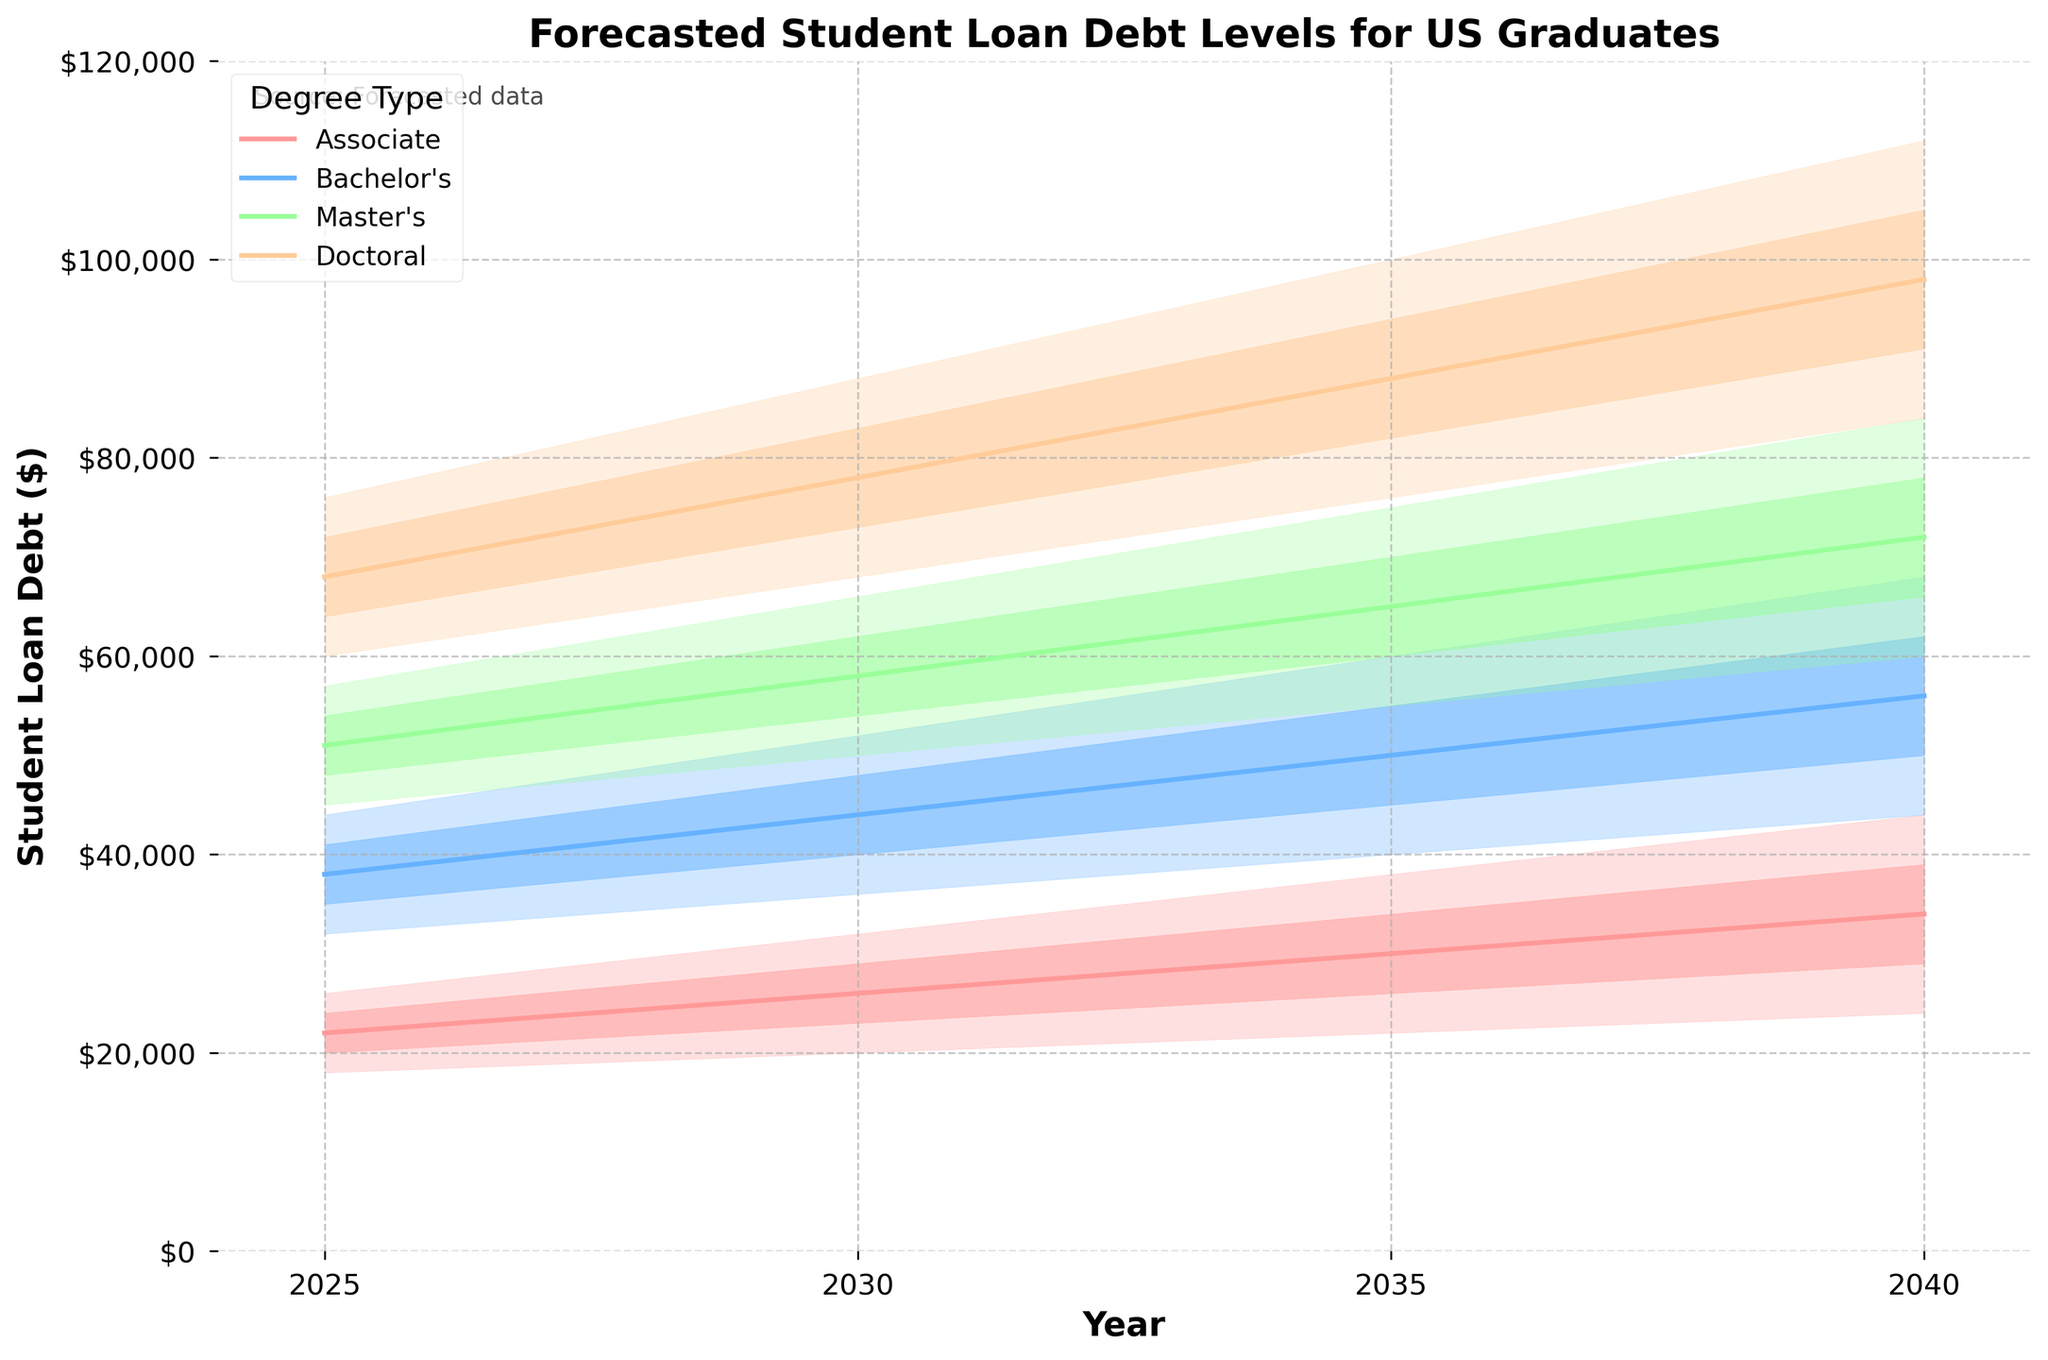What is the title of the figure? The title is usually the text at the top of the chart and provides a summary of what the chart is about. Here, the title located at the top center reads "Forecasted Student Loan Debt Levels for US Graduates."
Answer: Forecasted Student Loan Debt Levels for US Graduates What degrees are compared in this chart? The legend in the figure lists each degree type, each represented by a different color. According to the legend, the degrees compared are Associate, Bachelor's, Master's, and Doctoral.
Answer: Associate, Bachelor's, Master's, Doctoral Which degree type is forecasted to have the highest student loan debt in 2040? By examining the topmost band in 2040, we can see that the Doctoral degree has the highest range of loan debt, peaking at approximately $112,000.
Answer: Doctoral What is the range of forecasted loan debt for Master’s degree holders in 2030? The range is given by the low and high boundaries for the Master's degree in 2030. According to the data, these values are $50,000 (Low) and $66,000 (High).
Answer: $50,000 - $66,000 How does the median forecasted student loan debt for Bachelor's degree holders change from 2025 to 2040? The median values for Bachelor’s degree in 2025 and 2040 are $38,000 and $56,000 respectively. The difference is $56,000 - $38,000 = $18,000.
Answer: It increases by $18,000 Which degree type is expected to have the smallest increase in the high-end forecasted debt from 2025 to 2040? Compare the highest values for each degree type in 2025 and 2040. For Associate: $26,000 to $44,000 ($18,000 increase), Bachelor's: $44,000 to $68,000 ($24,000 increase), Master's: $57,000 to $84,000 ($27,000 increase), Doctoral: $76,000 to $112,000 ($36,000 increase). The smallest increase is for Associate degree holders ($18,000).
Answer: Associate What is the low-mid forecasted debt level for Associate degree holders in 2035? The low-mid value for Associate degree holders in 2035 is found in the data and is plotted on the chart within the colored bands. The value is $26,000.
Answer: $26,000 Between Bachelor's and Master's degree holders, who has a higher median forecasted debt in 2035? By looking at the median lines for both degree types in 2035, we find that Bachelor's is at $50,000 and Master's is at $65,000. Therefore, Master's holders have a higher median forecasted debt.
Answer: Master's How much higher is the projected maximum debt for a Doctoral degree in 2040 compared to an Associate degree? The projected maximum debt for a Doctoral degree in 2040 is $112,000, whereas for an Associate degree it is $44,000. The difference is $112,000 - $44,000 = $68,000.
Answer: $68,000 What indicates the uncertainty in the forecasted debt levels in the figure? The bands in each degree color indicate the uncertainty. Wider bands mean more uncertainty, while narrower bands mean less uncertainty. The range from "Low" to "High" for each degree in each year shows this variability.
Answer: The colored bands 